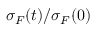<formula> <loc_0><loc_0><loc_500><loc_500>\sigma _ { F } ( t ) / \sigma _ { F } ( 0 )</formula> 